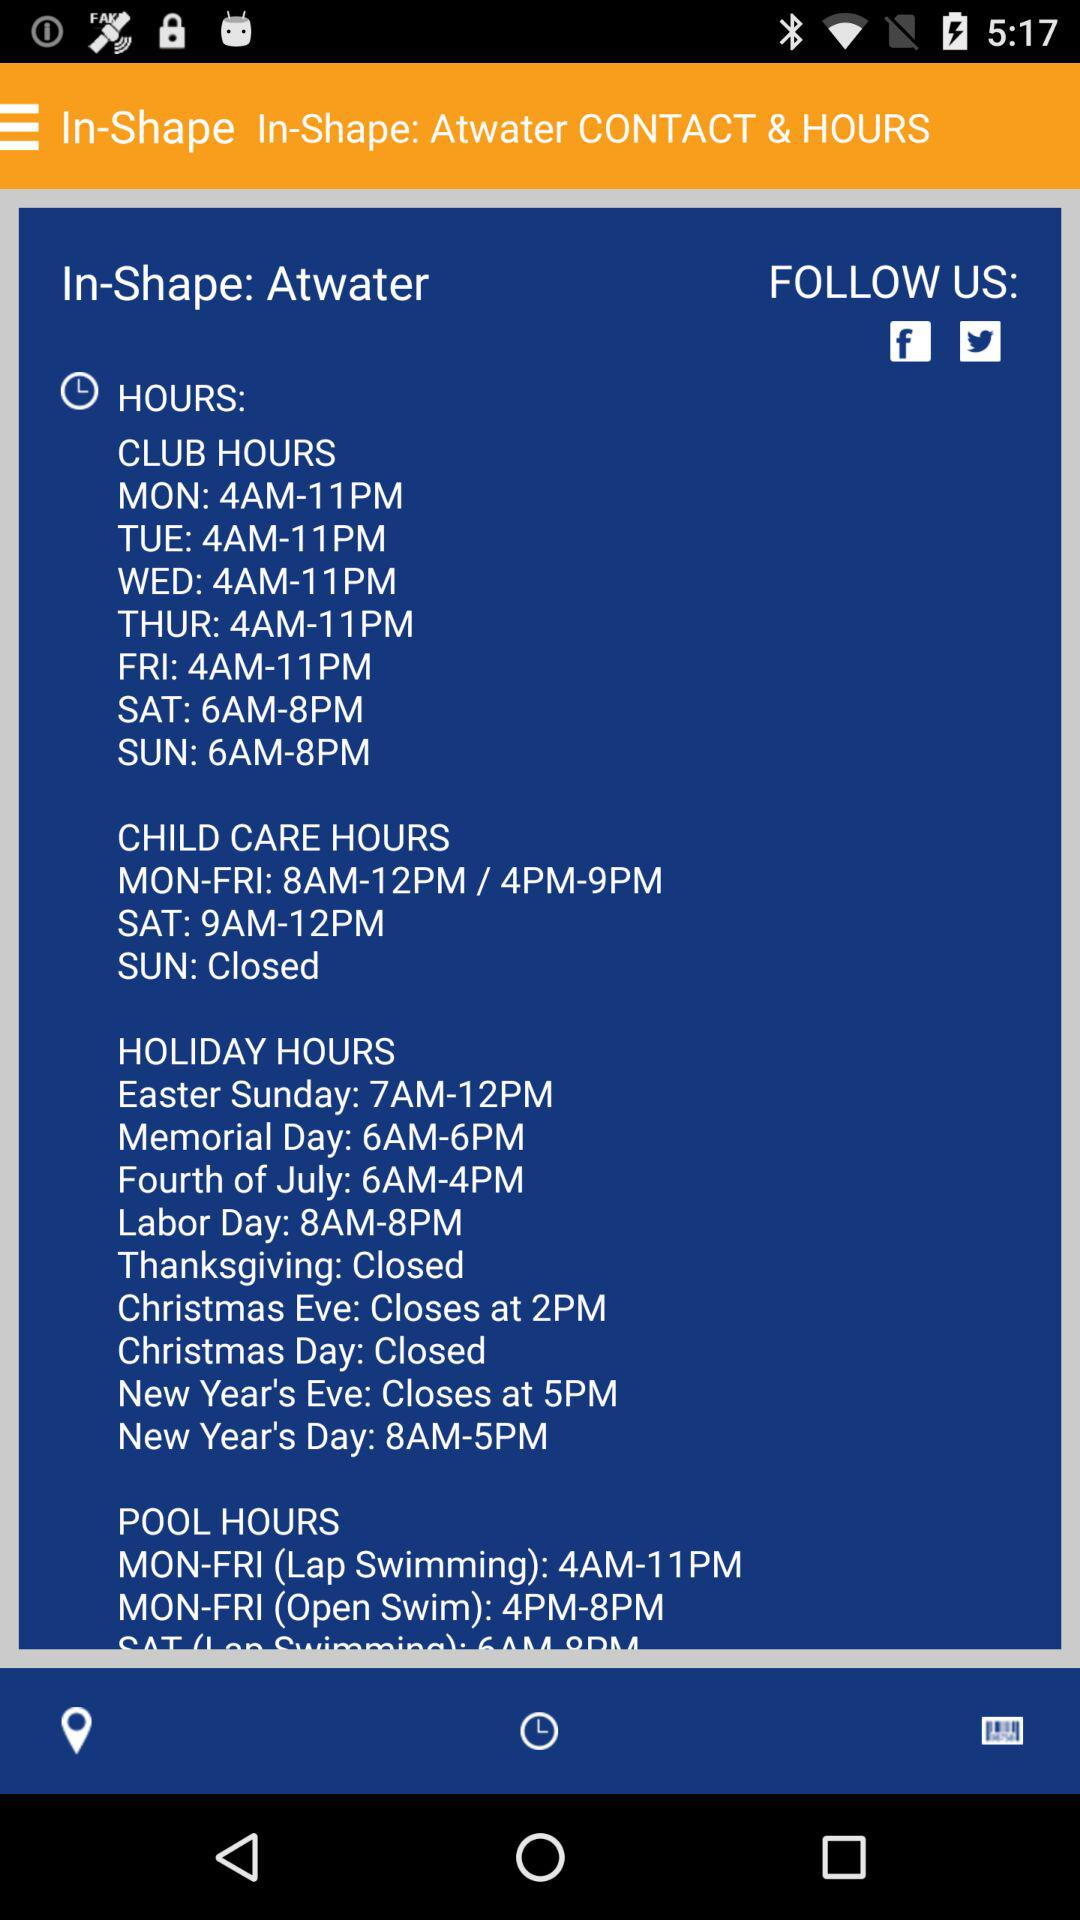What is the time duration for Easter Sunday? The time duration is between 7 a.m. and 12 p.m. 